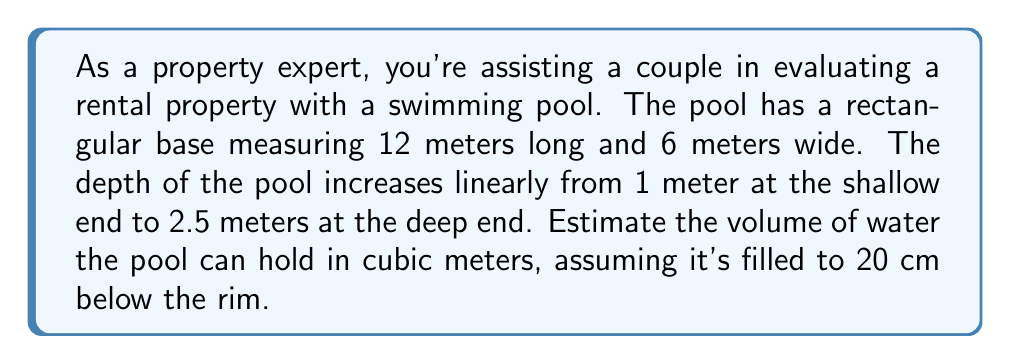Show me your answer to this math problem. To solve this problem, we need to calculate the volume of a rectangular prism with a sloped bottom. Let's break it down step-by-step:

1. Visualize the pool:
[asy]
import three;
size(200);
currentprojection=perspective(6,3,2);
draw(cuboid((0,0,0),(12,6,1)),blue);
draw(cuboid((0,0,1),(12,6,1.5)),blue);
draw((0,0,1)--(12,0,2.5)--(12,6,2.5)--(0,6,1)--cycle,blue);
label("12m",(6,0,0),S);
label("6m",(12,3,0),E);
label("1m",(0,0,0.5),W);
label("2.5m",(12,0,1.25),E);
[/asy]

2. Calculate the average depth:
   The depth increases linearly from 1m to 2.5m.
   Average depth = $\frac{1 \text{ m} + 2.5 \text{ m}}{2} = 1.75 \text{ m}$

3. Calculate the volume using the average depth:
   $V = \text{length} \times \text{width} \times \text{average depth}$
   $V = 12 \text{ m} \times 6 \text{ m} \times 1.75 \text{ m} = 126 \text{ m}^3$

4. Adjust for the 20 cm (0.2 m) unfilled space:
   Volume to subtract = $12 \text{ m} \times 6 \text{ m} \times 0.2 \text{ m} = 14.4 \text{ m}^3$

5. Calculate the final volume:
   Final volume = $126 \text{ m}^3 - 14.4 \text{ m}^3 = 111.6 \text{ m}^3$

Therefore, the estimated volume of water the pool can hold is 111.6 cubic meters.
Answer: $111.6 \text{ m}^3$ 